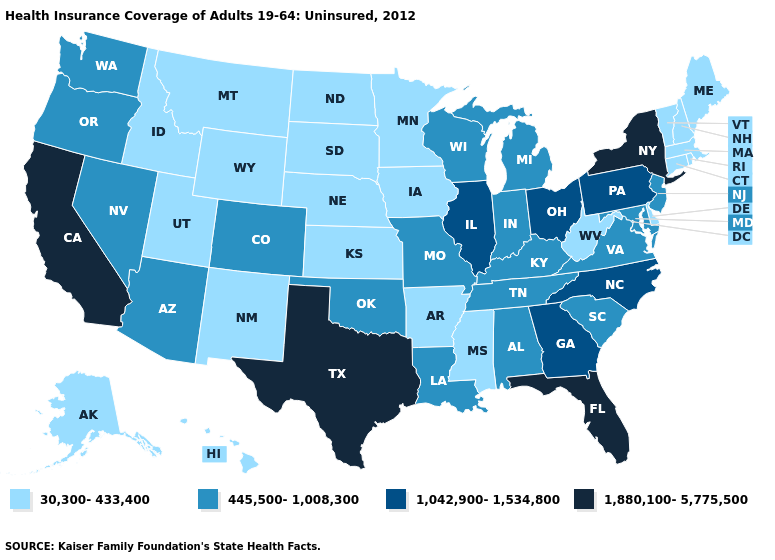Name the states that have a value in the range 1,042,900-1,534,800?
Keep it brief. Georgia, Illinois, North Carolina, Ohio, Pennsylvania. Does the map have missing data?
Concise answer only. No. Which states have the lowest value in the West?
Short answer required. Alaska, Hawaii, Idaho, Montana, New Mexico, Utah, Wyoming. Name the states that have a value in the range 445,500-1,008,300?
Be succinct. Alabama, Arizona, Colorado, Indiana, Kentucky, Louisiana, Maryland, Michigan, Missouri, Nevada, New Jersey, Oklahoma, Oregon, South Carolina, Tennessee, Virginia, Washington, Wisconsin. Name the states that have a value in the range 30,300-433,400?
Write a very short answer. Alaska, Arkansas, Connecticut, Delaware, Hawaii, Idaho, Iowa, Kansas, Maine, Massachusetts, Minnesota, Mississippi, Montana, Nebraska, New Hampshire, New Mexico, North Dakota, Rhode Island, South Dakota, Utah, Vermont, West Virginia, Wyoming. Which states hav the highest value in the West?
Quick response, please. California. What is the value of Michigan?
Give a very brief answer. 445,500-1,008,300. Which states have the highest value in the USA?
Keep it brief. California, Florida, New York, Texas. Which states have the highest value in the USA?
Short answer required. California, Florida, New York, Texas. Does Vermont have the lowest value in the Northeast?
Give a very brief answer. Yes. Among the states that border West Virginia , does Virginia have the highest value?
Quick response, please. No. What is the lowest value in the USA?
Give a very brief answer. 30,300-433,400. Among the states that border Pennsylvania , does Maryland have the lowest value?
Short answer required. No. What is the highest value in the Northeast ?
Be succinct. 1,880,100-5,775,500. Does New Hampshire have the lowest value in the Northeast?
Keep it brief. Yes. 